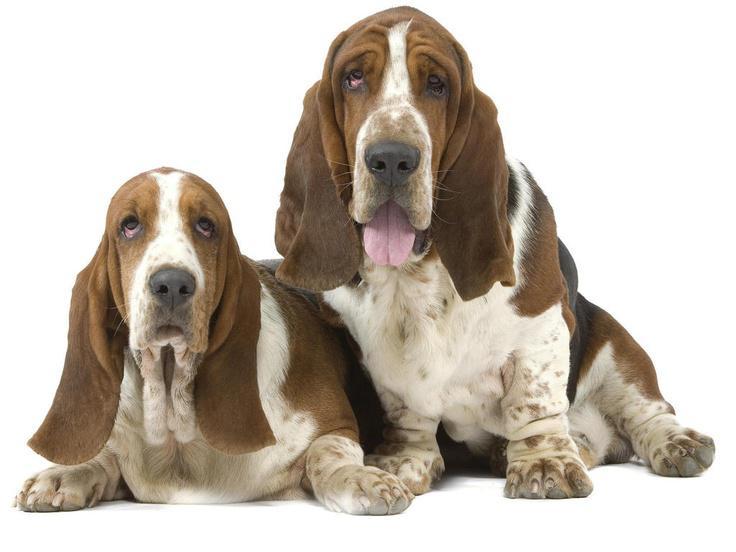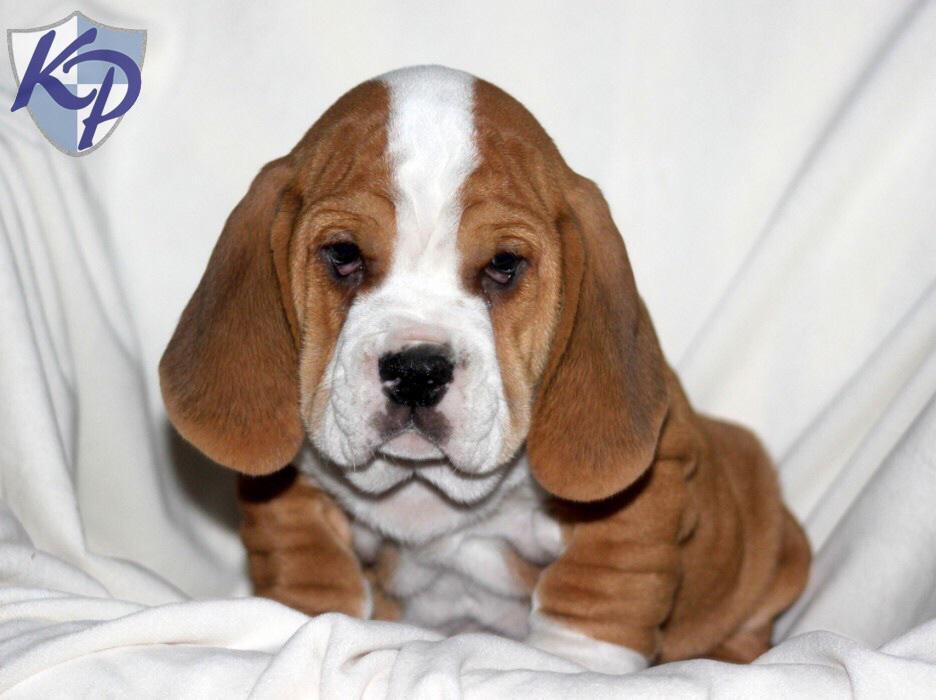The first image is the image on the left, the second image is the image on the right. For the images displayed, is the sentence "At least one of the dogs is outside." factually correct? Answer yes or no. No. The first image is the image on the left, the second image is the image on the right. For the images shown, is this caption "There is green vegetation visible in the background of at least one of the images." true? Answer yes or no. No. 